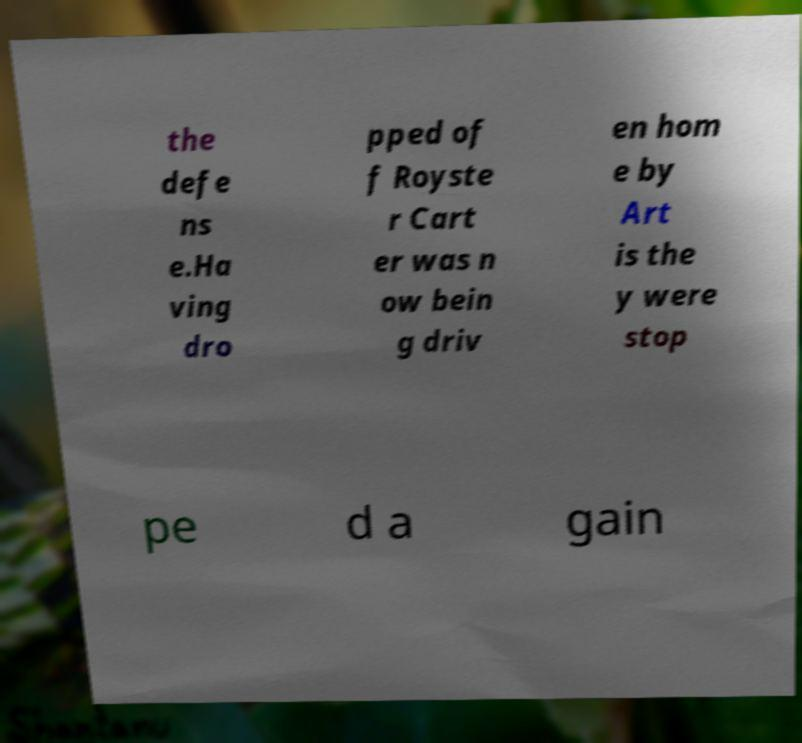Can you accurately transcribe the text from the provided image for me? the defe ns e.Ha ving dro pped of f Royste r Cart er was n ow bein g driv en hom e by Art is the y were stop pe d a gain 